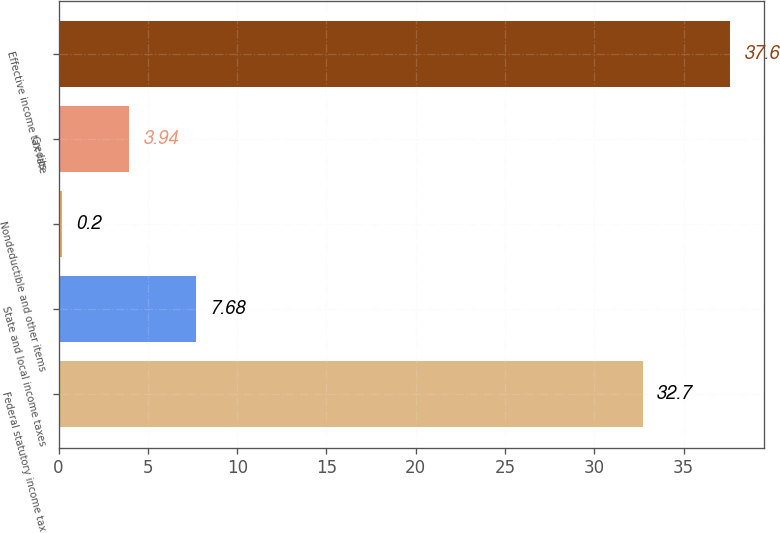<chart> <loc_0><loc_0><loc_500><loc_500><bar_chart><fcel>Federal statutory income tax<fcel>State and local income taxes<fcel>Nondeductible and other items<fcel>Credits<fcel>Effective income tax rate<nl><fcel>32.7<fcel>7.68<fcel>0.2<fcel>3.94<fcel>37.6<nl></chart> 